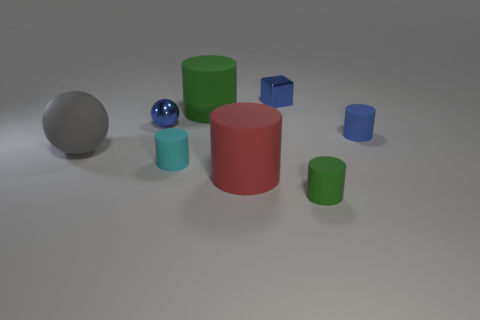Subtract all tiny cyan rubber cylinders. How many cylinders are left? 4 Subtract 2 cylinders. How many cylinders are left? 3 Subtract all red cylinders. How many cylinders are left? 4 Subtract all yellow cylinders. Subtract all brown balls. How many cylinders are left? 5 Add 1 gray matte things. How many objects exist? 9 Subtract all balls. How many objects are left? 6 Add 2 green things. How many green things exist? 4 Subtract 0 cyan spheres. How many objects are left? 8 Subtract all blocks. Subtract all red rubber objects. How many objects are left? 6 Add 3 tiny cyan rubber things. How many tiny cyan rubber things are left? 4 